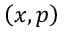Convert formula to latex. <formula><loc_0><loc_0><loc_500><loc_500>\left ( x , p \right )</formula> 